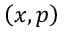Convert formula to latex. <formula><loc_0><loc_0><loc_500><loc_500>\left ( x , p \right )</formula> 